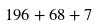Convert formula to latex. <formula><loc_0><loc_0><loc_500><loc_500>1 9 6 + 6 8 + 7</formula> 